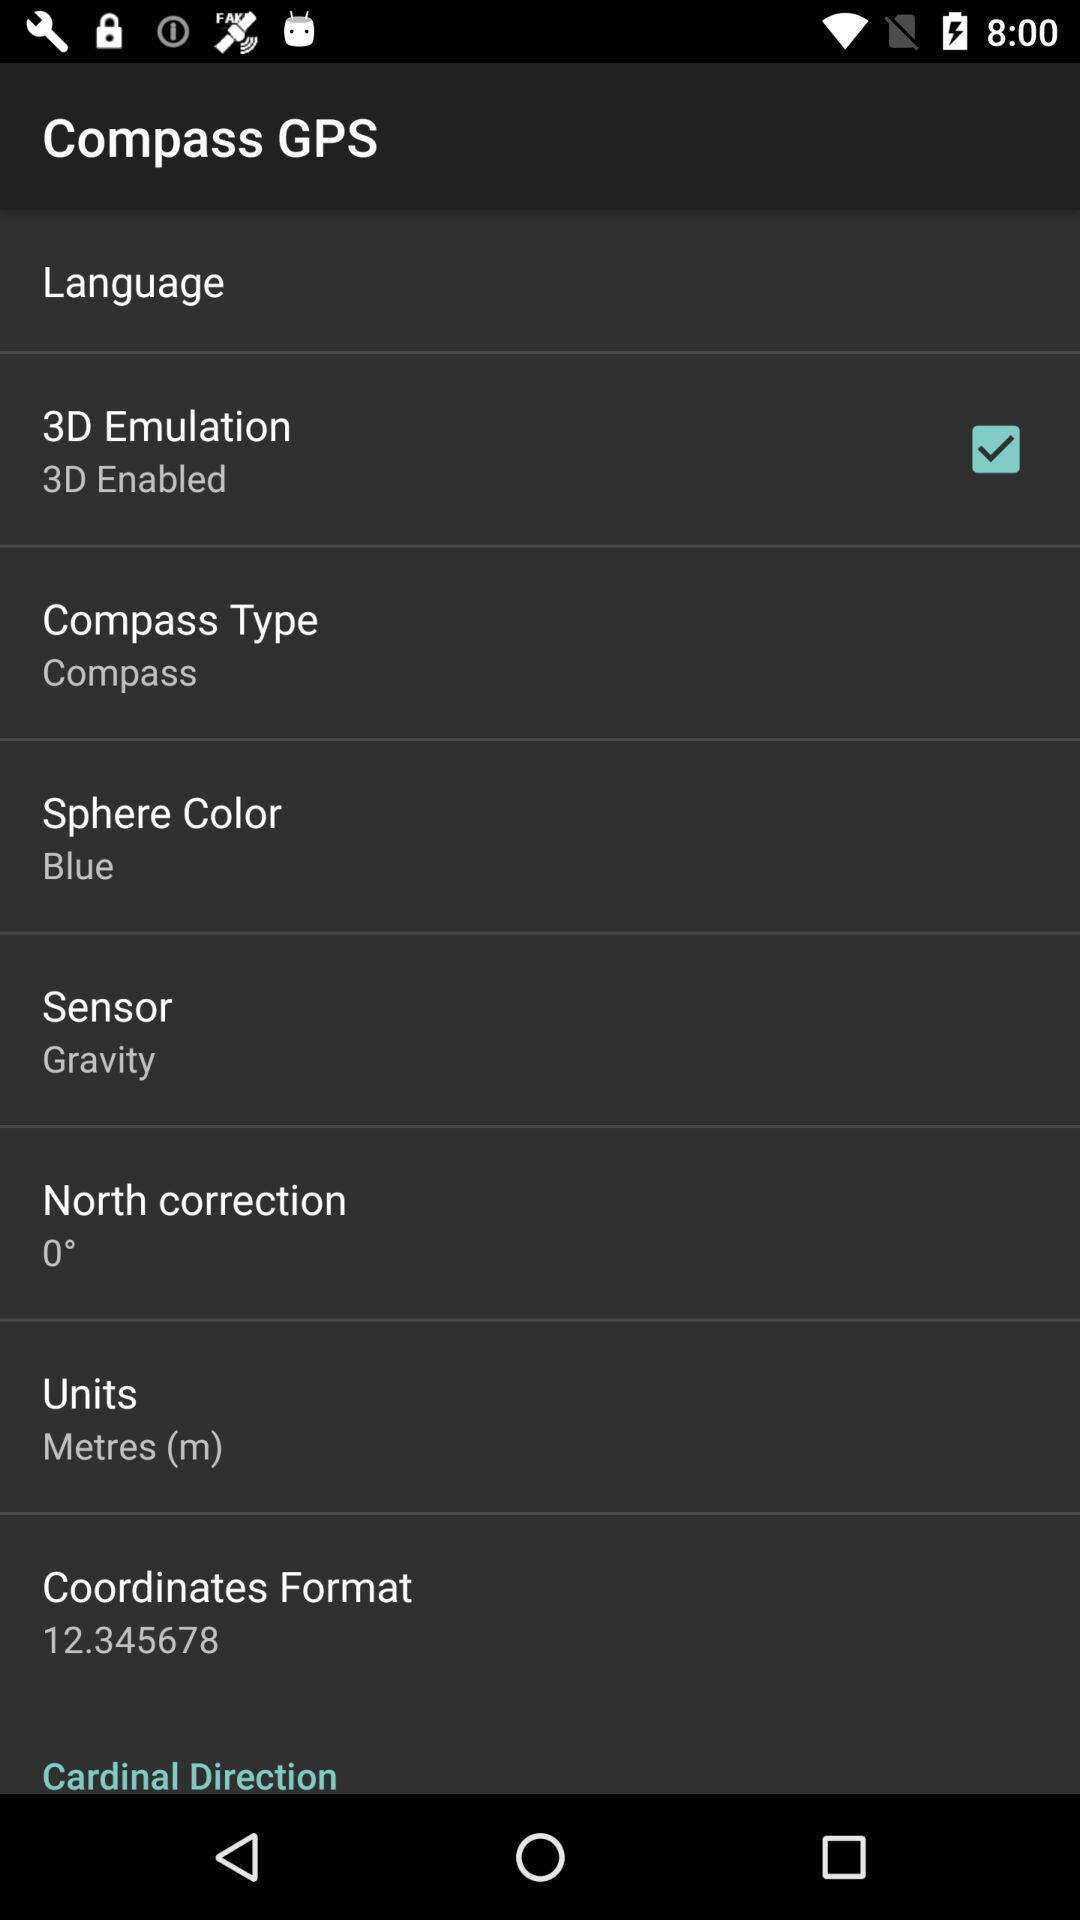What is the accuracy of GPS? The accuracy is 2 meters. 